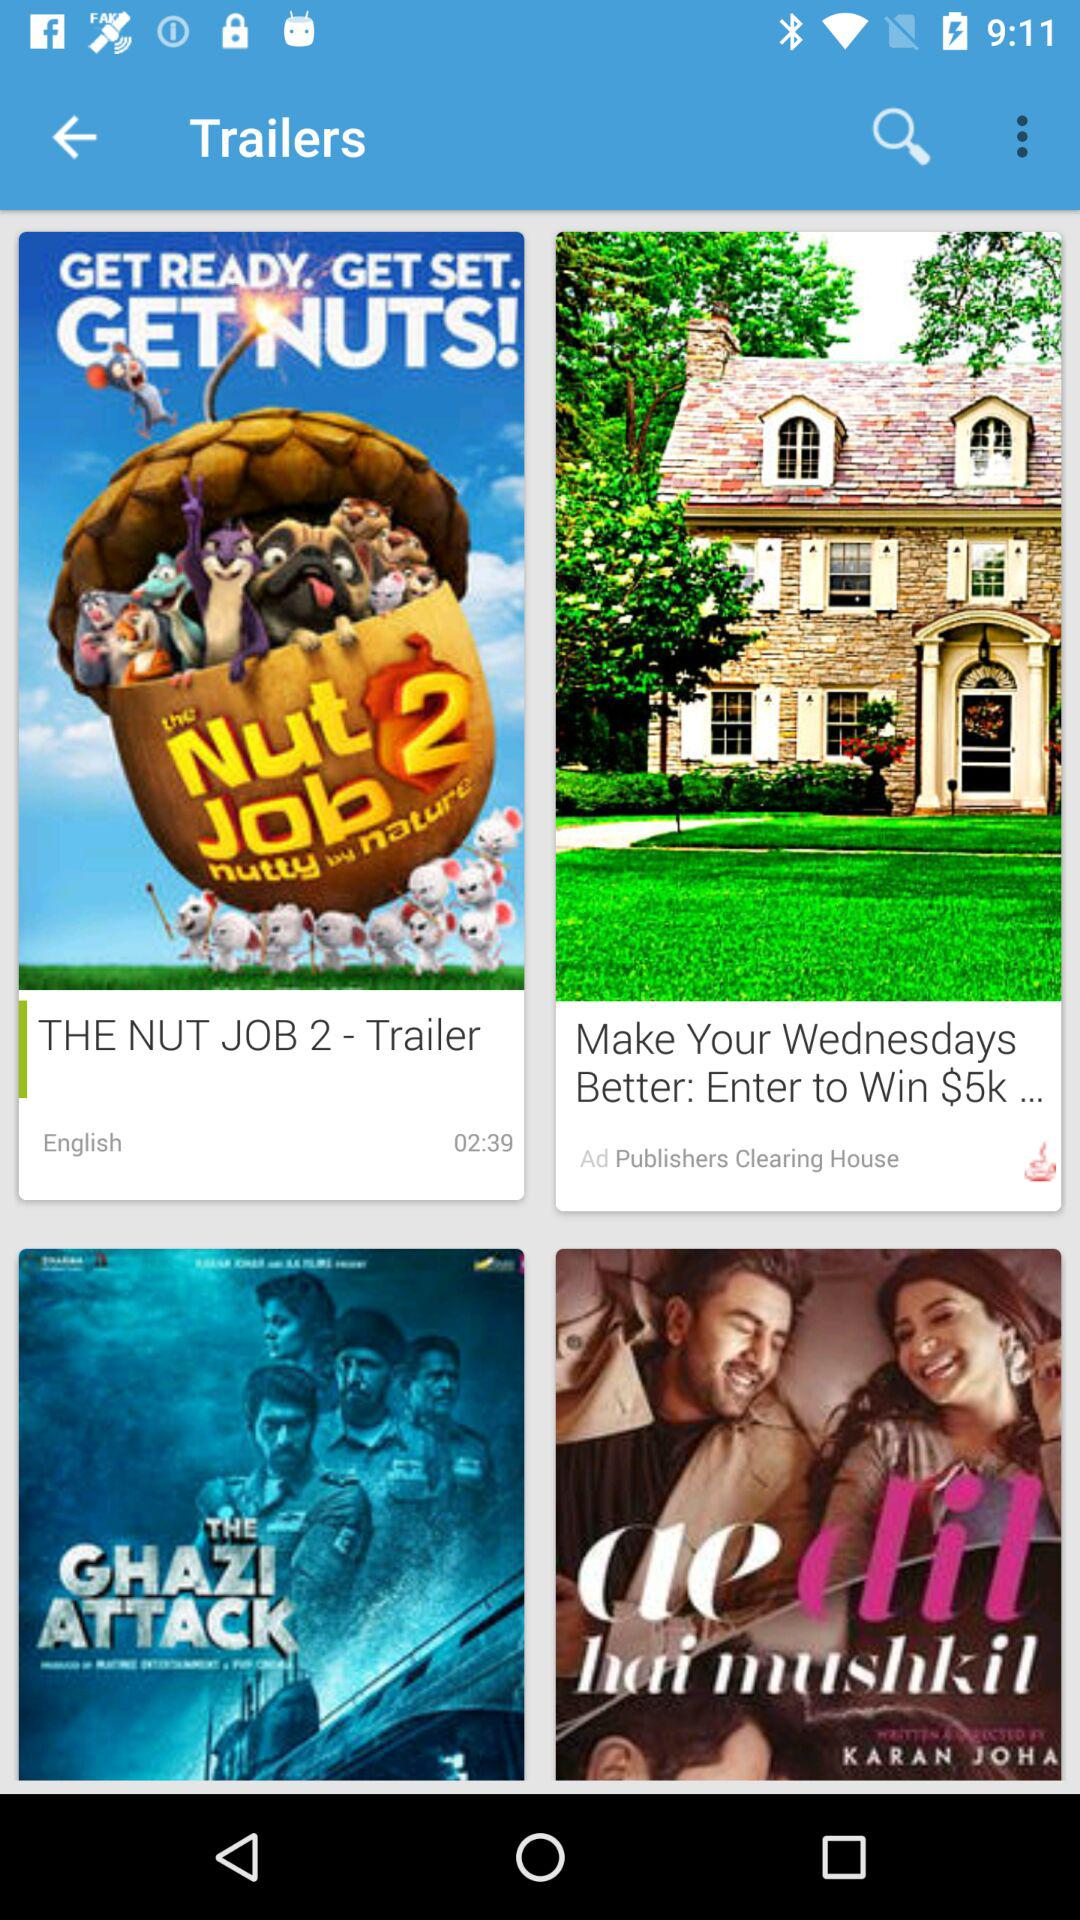How long is the Publishers Clearing House ad?
When the provided information is insufficient, respond with <no answer>. <no answer> 